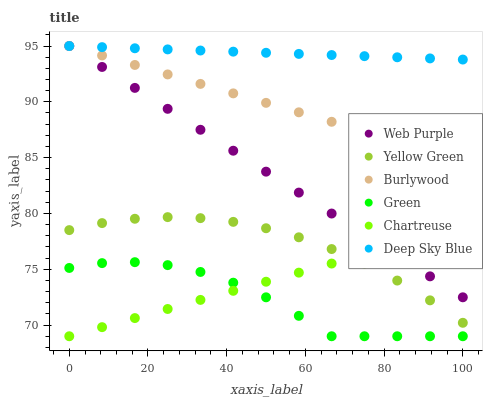Does Green have the minimum area under the curve?
Answer yes or no. Yes. Does Deep Sky Blue have the maximum area under the curve?
Answer yes or no. Yes. Does Burlywood have the minimum area under the curve?
Answer yes or no. No. Does Burlywood have the maximum area under the curve?
Answer yes or no. No. Is Deep Sky Blue the smoothest?
Answer yes or no. Yes. Is Green the roughest?
Answer yes or no. Yes. Is Burlywood the smoothest?
Answer yes or no. No. Is Burlywood the roughest?
Answer yes or no. No. Does Chartreuse have the lowest value?
Answer yes or no. Yes. Does Burlywood have the lowest value?
Answer yes or no. No. Does Deep Sky Blue have the highest value?
Answer yes or no. Yes. Does Chartreuse have the highest value?
Answer yes or no. No. Is Yellow Green less than Web Purple?
Answer yes or no. Yes. Is Deep Sky Blue greater than Chartreuse?
Answer yes or no. Yes. Does Chartreuse intersect Yellow Green?
Answer yes or no. Yes. Is Chartreuse less than Yellow Green?
Answer yes or no. No. Is Chartreuse greater than Yellow Green?
Answer yes or no. No. Does Yellow Green intersect Web Purple?
Answer yes or no. No. 